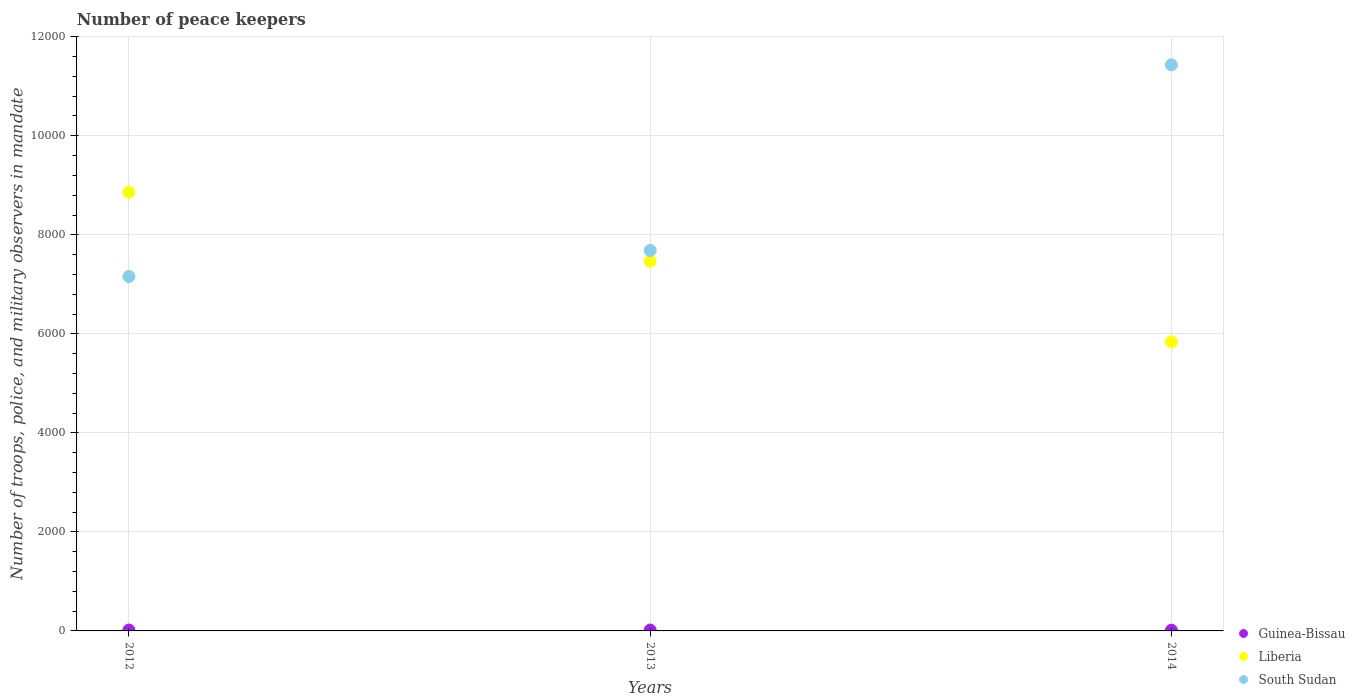Is the number of dotlines equal to the number of legend labels?
Give a very brief answer. Yes. What is the number of peace keepers in in Liberia in 2014?
Your answer should be compact. 5838. Across all years, what is the maximum number of peace keepers in in Liberia?
Keep it short and to the point. 8862. In which year was the number of peace keepers in in Guinea-Bissau maximum?
Your answer should be compact. 2012. What is the total number of peace keepers in in South Sudan in the graph?
Your answer should be very brief. 2.63e+04. What is the difference between the number of peace keepers in in South Sudan in 2013 and that in 2014?
Provide a short and direct response. -3749. What is the difference between the number of peace keepers in in Guinea-Bissau in 2013 and the number of peace keepers in in Liberia in 2014?
Your answer should be very brief. -5820. What is the average number of peace keepers in in South Sudan per year?
Provide a short and direct response. 8758. In the year 2012, what is the difference between the number of peace keepers in in Guinea-Bissau and number of peace keepers in in Liberia?
Give a very brief answer. -8844. What is the ratio of the number of peace keepers in in Guinea-Bissau in 2012 to that in 2014?
Ensure brevity in your answer.  1.29. Is the number of peace keepers in in Guinea-Bissau in 2013 less than that in 2014?
Your response must be concise. No. What is the difference between the highest and the second highest number of peace keepers in in Liberia?
Your answer should be compact. 1395. Is it the case that in every year, the sum of the number of peace keepers in in South Sudan and number of peace keepers in in Liberia  is greater than the number of peace keepers in in Guinea-Bissau?
Your answer should be compact. Yes. Is the number of peace keepers in in Liberia strictly greater than the number of peace keepers in in South Sudan over the years?
Ensure brevity in your answer.  No. How many dotlines are there?
Your response must be concise. 3. Are the values on the major ticks of Y-axis written in scientific E-notation?
Ensure brevity in your answer.  No. Does the graph contain any zero values?
Your answer should be very brief. No. Does the graph contain grids?
Give a very brief answer. Yes. What is the title of the graph?
Make the answer very short. Number of peace keepers. What is the label or title of the X-axis?
Give a very brief answer. Years. What is the label or title of the Y-axis?
Keep it short and to the point. Number of troops, police, and military observers in mandate. What is the Number of troops, police, and military observers in mandate of Liberia in 2012?
Provide a short and direct response. 8862. What is the Number of troops, police, and military observers in mandate of South Sudan in 2012?
Your response must be concise. 7157. What is the Number of troops, police, and military observers in mandate of Liberia in 2013?
Provide a succinct answer. 7467. What is the Number of troops, police, and military observers in mandate in South Sudan in 2013?
Ensure brevity in your answer.  7684. What is the Number of troops, police, and military observers in mandate in Liberia in 2014?
Give a very brief answer. 5838. What is the Number of troops, police, and military observers in mandate of South Sudan in 2014?
Your response must be concise. 1.14e+04. Across all years, what is the maximum Number of troops, police, and military observers in mandate of Liberia?
Your answer should be very brief. 8862. Across all years, what is the maximum Number of troops, police, and military observers in mandate in South Sudan?
Your answer should be very brief. 1.14e+04. Across all years, what is the minimum Number of troops, police, and military observers in mandate in Guinea-Bissau?
Offer a terse response. 14. Across all years, what is the minimum Number of troops, police, and military observers in mandate of Liberia?
Ensure brevity in your answer.  5838. Across all years, what is the minimum Number of troops, police, and military observers in mandate of South Sudan?
Provide a short and direct response. 7157. What is the total Number of troops, police, and military observers in mandate in Guinea-Bissau in the graph?
Provide a short and direct response. 50. What is the total Number of troops, police, and military observers in mandate in Liberia in the graph?
Your answer should be very brief. 2.22e+04. What is the total Number of troops, police, and military observers in mandate in South Sudan in the graph?
Offer a very short reply. 2.63e+04. What is the difference between the Number of troops, police, and military observers in mandate of Liberia in 2012 and that in 2013?
Give a very brief answer. 1395. What is the difference between the Number of troops, police, and military observers in mandate of South Sudan in 2012 and that in 2013?
Keep it short and to the point. -527. What is the difference between the Number of troops, police, and military observers in mandate of Guinea-Bissau in 2012 and that in 2014?
Your answer should be very brief. 4. What is the difference between the Number of troops, police, and military observers in mandate of Liberia in 2012 and that in 2014?
Your response must be concise. 3024. What is the difference between the Number of troops, police, and military observers in mandate of South Sudan in 2012 and that in 2014?
Provide a short and direct response. -4276. What is the difference between the Number of troops, police, and military observers in mandate of Guinea-Bissau in 2013 and that in 2014?
Your response must be concise. 4. What is the difference between the Number of troops, police, and military observers in mandate in Liberia in 2013 and that in 2014?
Your answer should be very brief. 1629. What is the difference between the Number of troops, police, and military observers in mandate in South Sudan in 2013 and that in 2014?
Offer a terse response. -3749. What is the difference between the Number of troops, police, and military observers in mandate of Guinea-Bissau in 2012 and the Number of troops, police, and military observers in mandate of Liberia in 2013?
Make the answer very short. -7449. What is the difference between the Number of troops, police, and military observers in mandate of Guinea-Bissau in 2012 and the Number of troops, police, and military observers in mandate of South Sudan in 2013?
Provide a short and direct response. -7666. What is the difference between the Number of troops, police, and military observers in mandate in Liberia in 2012 and the Number of troops, police, and military observers in mandate in South Sudan in 2013?
Keep it short and to the point. 1178. What is the difference between the Number of troops, police, and military observers in mandate of Guinea-Bissau in 2012 and the Number of troops, police, and military observers in mandate of Liberia in 2014?
Your response must be concise. -5820. What is the difference between the Number of troops, police, and military observers in mandate of Guinea-Bissau in 2012 and the Number of troops, police, and military observers in mandate of South Sudan in 2014?
Offer a terse response. -1.14e+04. What is the difference between the Number of troops, police, and military observers in mandate of Liberia in 2012 and the Number of troops, police, and military observers in mandate of South Sudan in 2014?
Offer a terse response. -2571. What is the difference between the Number of troops, police, and military observers in mandate in Guinea-Bissau in 2013 and the Number of troops, police, and military observers in mandate in Liberia in 2014?
Keep it short and to the point. -5820. What is the difference between the Number of troops, police, and military observers in mandate in Guinea-Bissau in 2013 and the Number of troops, police, and military observers in mandate in South Sudan in 2014?
Your response must be concise. -1.14e+04. What is the difference between the Number of troops, police, and military observers in mandate in Liberia in 2013 and the Number of troops, police, and military observers in mandate in South Sudan in 2014?
Your answer should be very brief. -3966. What is the average Number of troops, police, and military observers in mandate of Guinea-Bissau per year?
Offer a very short reply. 16.67. What is the average Number of troops, police, and military observers in mandate in Liberia per year?
Offer a terse response. 7389. What is the average Number of troops, police, and military observers in mandate in South Sudan per year?
Ensure brevity in your answer.  8758. In the year 2012, what is the difference between the Number of troops, police, and military observers in mandate in Guinea-Bissau and Number of troops, police, and military observers in mandate in Liberia?
Ensure brevity in your answer.  -8844. In the year 2012, what is the difference between the Number of troops, police, and military observers in mandate in Guinea-Bissau and Number of troops, police, and military observers in mandate in South Sudan?
Make the answer very short. -7139. In the year 2012, what is the difference between the Number of troops, police, and military observers in mandate of Liberia and Number of troops, police, and military observers in mandate of South Sudan?
Ensure brevity in your answer.  1705. In the year 2013, what is the difference between the Number of troops, police, and military observers in mandate of Guinea-Bissau and Number of troops, police, and military observers in mandate of Liberia?
Make the answer very short. -7449. In the year 2013, what is the difference between the Number of troops, police, and military observers in mandate of Guinea-Bissau and Number of troops, police, and military observers in mandate of South Sudan?
Provide a succinct answer. -7666. In the year 2013, what is the difference between the Number of troops, police, and military observers in mandate of Liberia and Number of troops, police, and military observers in mandate of South Sudan?
Make the answer very short. -217. In the year 2014, what is the difference between the Number of troops, police, and military observers in mandate of Guinea-Bissau and Number of troops, police, and military observers in mandate of Liberia?
Provide a succinct answer. -5824. In the year 2014, what is the difference between the Number of troops, police, and military observers in mandate of Guinea-Bissau and Number of troops, police, and military observers in mandate of South Sudan?
Your response must be concise. -1.14e+04. In the year 2014, what is the difference between the Number of troops, police, and military observers in mandate of Liberia and Number of troops, police, and military observers in mandate of South Sudan?
Keep it short and to the point. -5595. What is the ratio of the Number of troops, police, and military observers in mandate in Guinea-Bissau in 2012 to that in 2013?
Ensure brevity in your answer.  1. What is the ratio of the Number of troops, police, and military observers in mandate of Liberia in 2012 to that in 2013?
Make the answer very short. 1.19. What is the ratio of the Number of troops, police, and military observers in mandate of South Sudan in 2012 to that in 2013?
Ensure brevity in your answer.  0.93. What is the ratio of the Number of troops, police, and military observers in mandate in Guinea-Bissau in 2012 to that in 2014?
Offer a terse response. 1.29. What is the ratio of the Number of troops, police, and military observers in mandate in Liberia in 2012 to that in 2014?
Your answer should be very brief. 1.52. What is the ratio of the Number of troops, police, and military observers in mandate in South Sudan in 2012 to that in 2014?
Give a very brief answer. 0.63. What is the ratio of the Number of troops, police, and military observers in mandate in Guinea-Bissau in 2013 to that in 2014?
Give a very brief answer. 1.29. What is the ratio of the Number of troops, police, and military observers in mandate in Liberia in 2013 to that in 2014?
Offer a very short reply. 1.28. What is the ratio of the Number of troops, police, and military observers in mandate of South Sudan in 2013 to that in 2014?
Offer a very short reply. 0.67. What is the difference between the highest and the second highest Number of troops, police, and military observers in mandate in Guinea-Bissau?
Your answer should be compact. 0. What is the difference between the highest and the second highest Number of troops, police, and military observers in mandate of Liberia?
Provide a succinct answer. 1395. What is the difference between the highest and the second highest Number of troops, police, and military observers in mandate in South Sudan?
Provide a succinct answer. 3749. What is the difference between the highest and the lowest Number of troops, police, and military observers in mandate of Liberia?
Offer a terse response. 3024. What is the difference between the highest and the lowest Number of troops, police, and military observers in mandate in South Sudan?
Keep it short and to the point. 4276. 